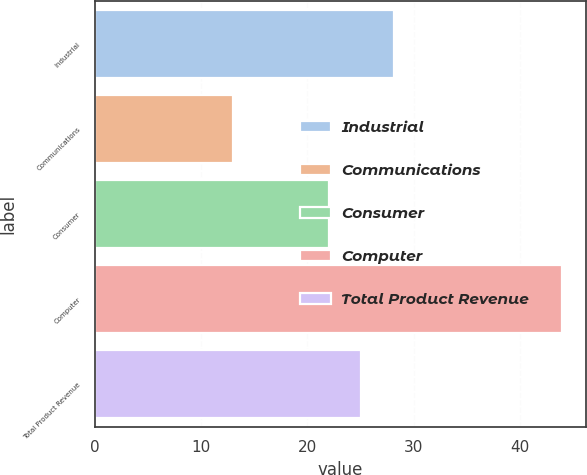Convert chart. <chart><loc_0><loc_0><loc_500><loc_500><bar_chart><fcel>Industrial<fcel>Communications<fcel>Consumer<fcel>Computer<fcel>Total Product Revenue<nl><fcel>28.2<fcel>13<fcel>22<fcel>44<fcel>25.1<nl></chart> 